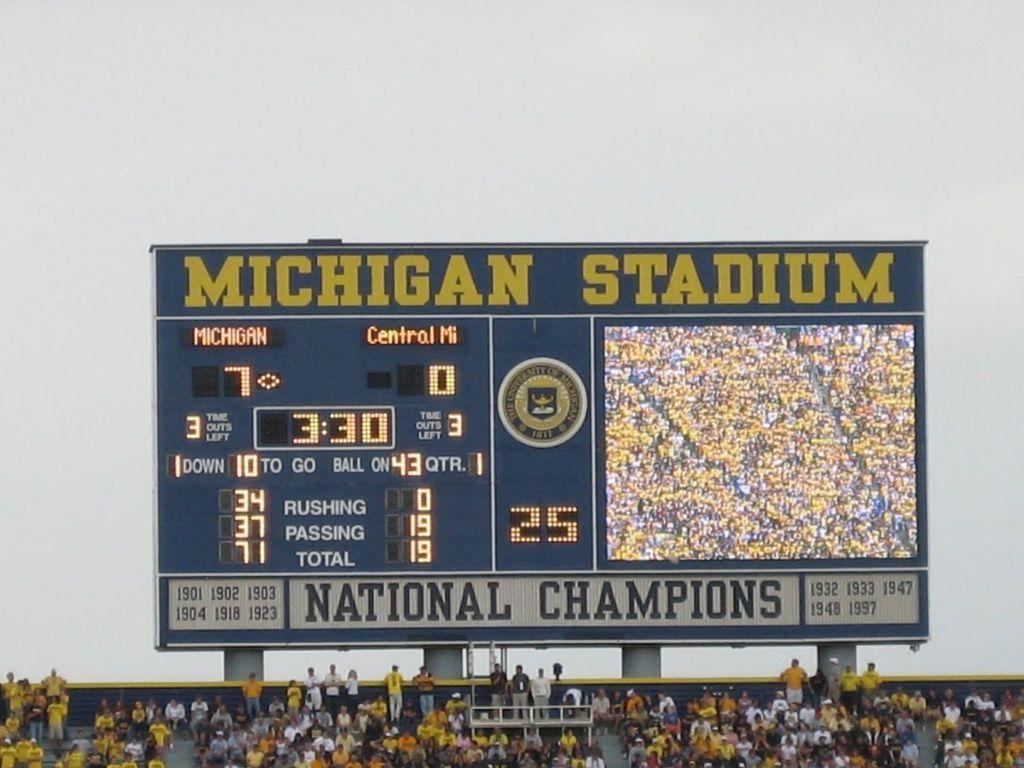<image>
Give a short and clear explanation of the subsequent image. The scoreboard at Michigan Stadium shows the score between Michigan and Central Michigan. 